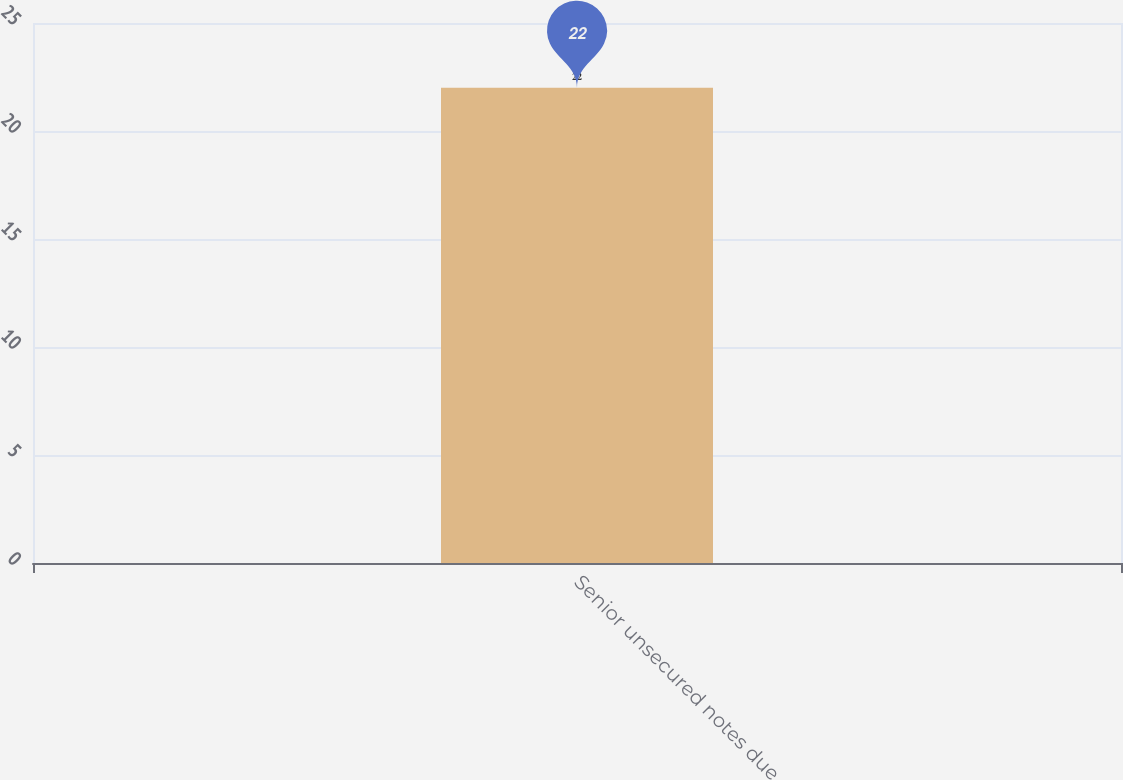Convert chart. <chart><loc_0><loc_0><loc_500><loc_500><bar_chart><fcel>Senior unsecured notes due<nl><fcel>22<nl></chart> 